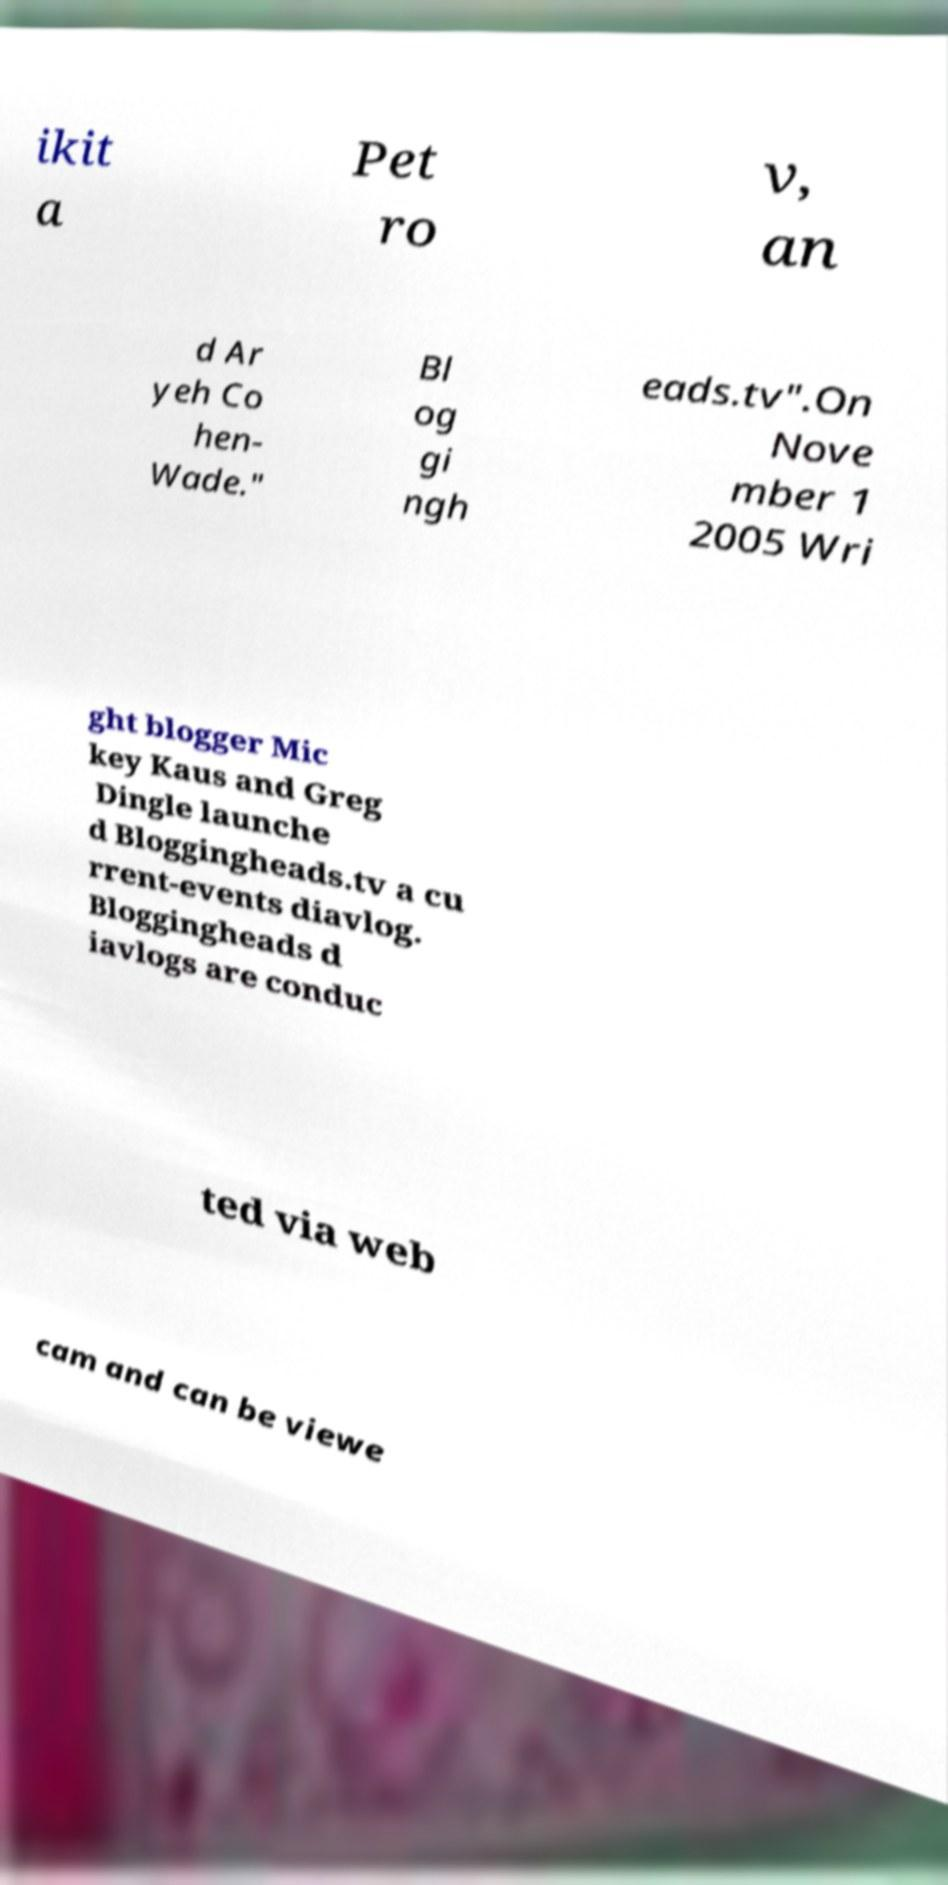Please read and relay the text visible in this image. What does it say? ikit a Pet ro v, an d Ar yeh Co hen- Wade." Bl og gi ngh eads.tv".On Nove mber 1 2005 Wri ght blogger Mic key Kaus and Greg Dingle launche d Bloggingheads.tv a cu rrent-events diavlog. Bloggingheads d iavlogs are conduc ted via web cam and can be viewe 